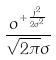Convert formula to latex. <formula><loc_0><loc_0><loc_500><loc_500>\frac { o ^ { + \frac { j ^ { 2 } } { 2 \sigma ^ { 2 } } } } { \sqrt { 2 \pi } \sigma }</formula> 